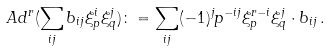Convert formula to latex. <formula><loc_0><loc_0><loc_500><loc_500>A d ^ { r } ( \sum _ { i j } b _ { i j } \xi _ { p } ^ { i } \xi _ { q } ^ { j } ) \colon = \sum _ { i j } ( - 1 ) ^ { j } p ^ { - i j } \xi _ { p } ^ { r - i } \xi _ { q } ^ { j } \cdot b _ { i j } \, .</formula> 